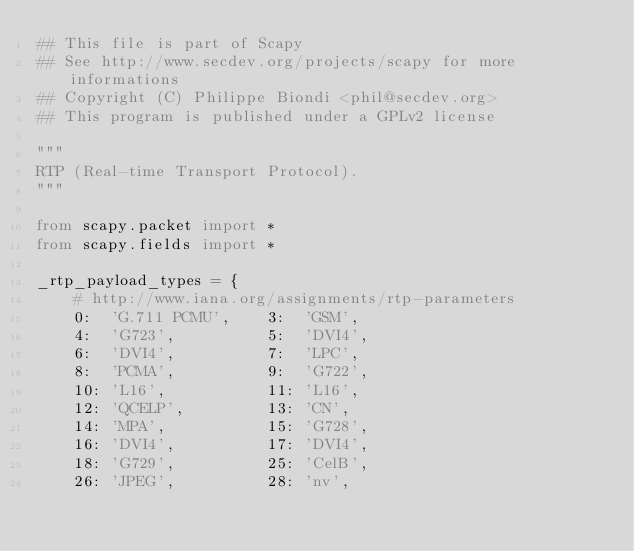Convert code to text. <code><loc_0><loc_0><loc_500><loc_500><_Python_>## This file is part of Scapy
## See http://www.secdev.org/projects/scapy for more informations
## Copyright (C) Philippe Biondi <phil@secdev.org>
## This program is published under a GPLv2 license

"""
RTP (Real-time Transport Protocol).
"""

from scapy.packet import *
from scapy.fields import *

_rtp_payload_types = {
    # http://www.iana.org/assignments/rtp-parameters
    0:  'G.711 PCMU',    3:  'GSM',
    4:  'G723',          5:  'DVI4',
    6:  'DVI4',          7:  'LPC',
    8:  'PCMA',          9:  'G722',
    10: 'L16',           11: 'L16',
    12: 'QCELP',         13: 'CN',
    14: 'MPA',           15: 'G728',
    16: 'DVI4',          17: 'DVI4',
    18: 'G729',          25: 'CelB',
    26: 'JPEG',          28: 'nv',</code> 